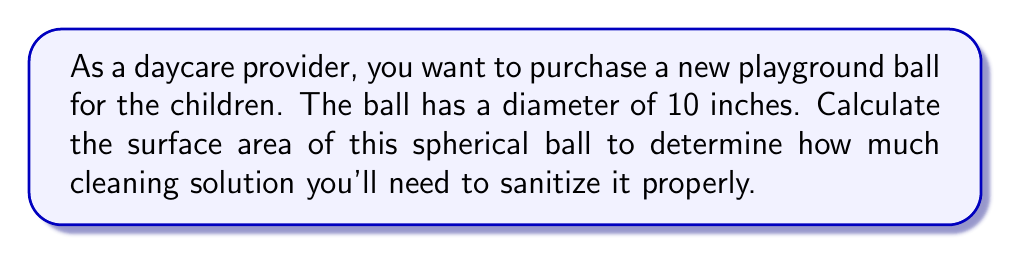Help me with this question. To solve this problem, we'll follow these steps:

1) Recall the formula for the surface area of a sphere:
   $$A = 4\pi r^2$$
   where $A$ is the surface area and $r$ is the radius of the sphere.

2) We're given the diameter of the ball, which is 10 inches. The radius is half of the diameter:
   $$r = \frac{10}{2} = 5 \text{ inches}$$

3) Now, let's substitute this value into our formula:
   $$A = 4\pi (5)^2$$

4) Simplify:
   $$A = 4\pi (25)$$
   $$A = 100\pi \text{ square inches}$$

5) If we want to express this as a decimal, we can multiply by $\pi \approx 3.14159$:
   $$A \approx 100 * 3.14159 \approx 314.159 \text{ square inches}$$

Therefore, the surface area of the playground ball is $100\pi$ or approximately 314.159 square inches.
Answer: $100\pi$ square inches, or approximately 314.159 square inches 